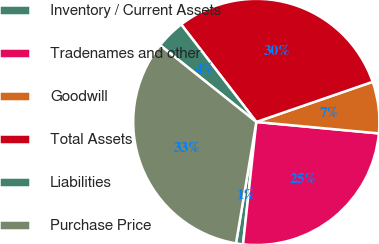Convert chart to OTSL. <chart><loc_0><loc_0><loc_500><loc_500><pie_chart><fcel>Inventory / Current Assets<fcel>Tradenames and other<fcel>Goodwill<fcel>Total Assets<fcel>Liabilities<fcel>Purchase Price<nl><fcel>0.92%<fcel>25.24%<fcel>6.77%<fcel>30.16%<fcel>3.84%<fcel>33.08%<nl></chart> 